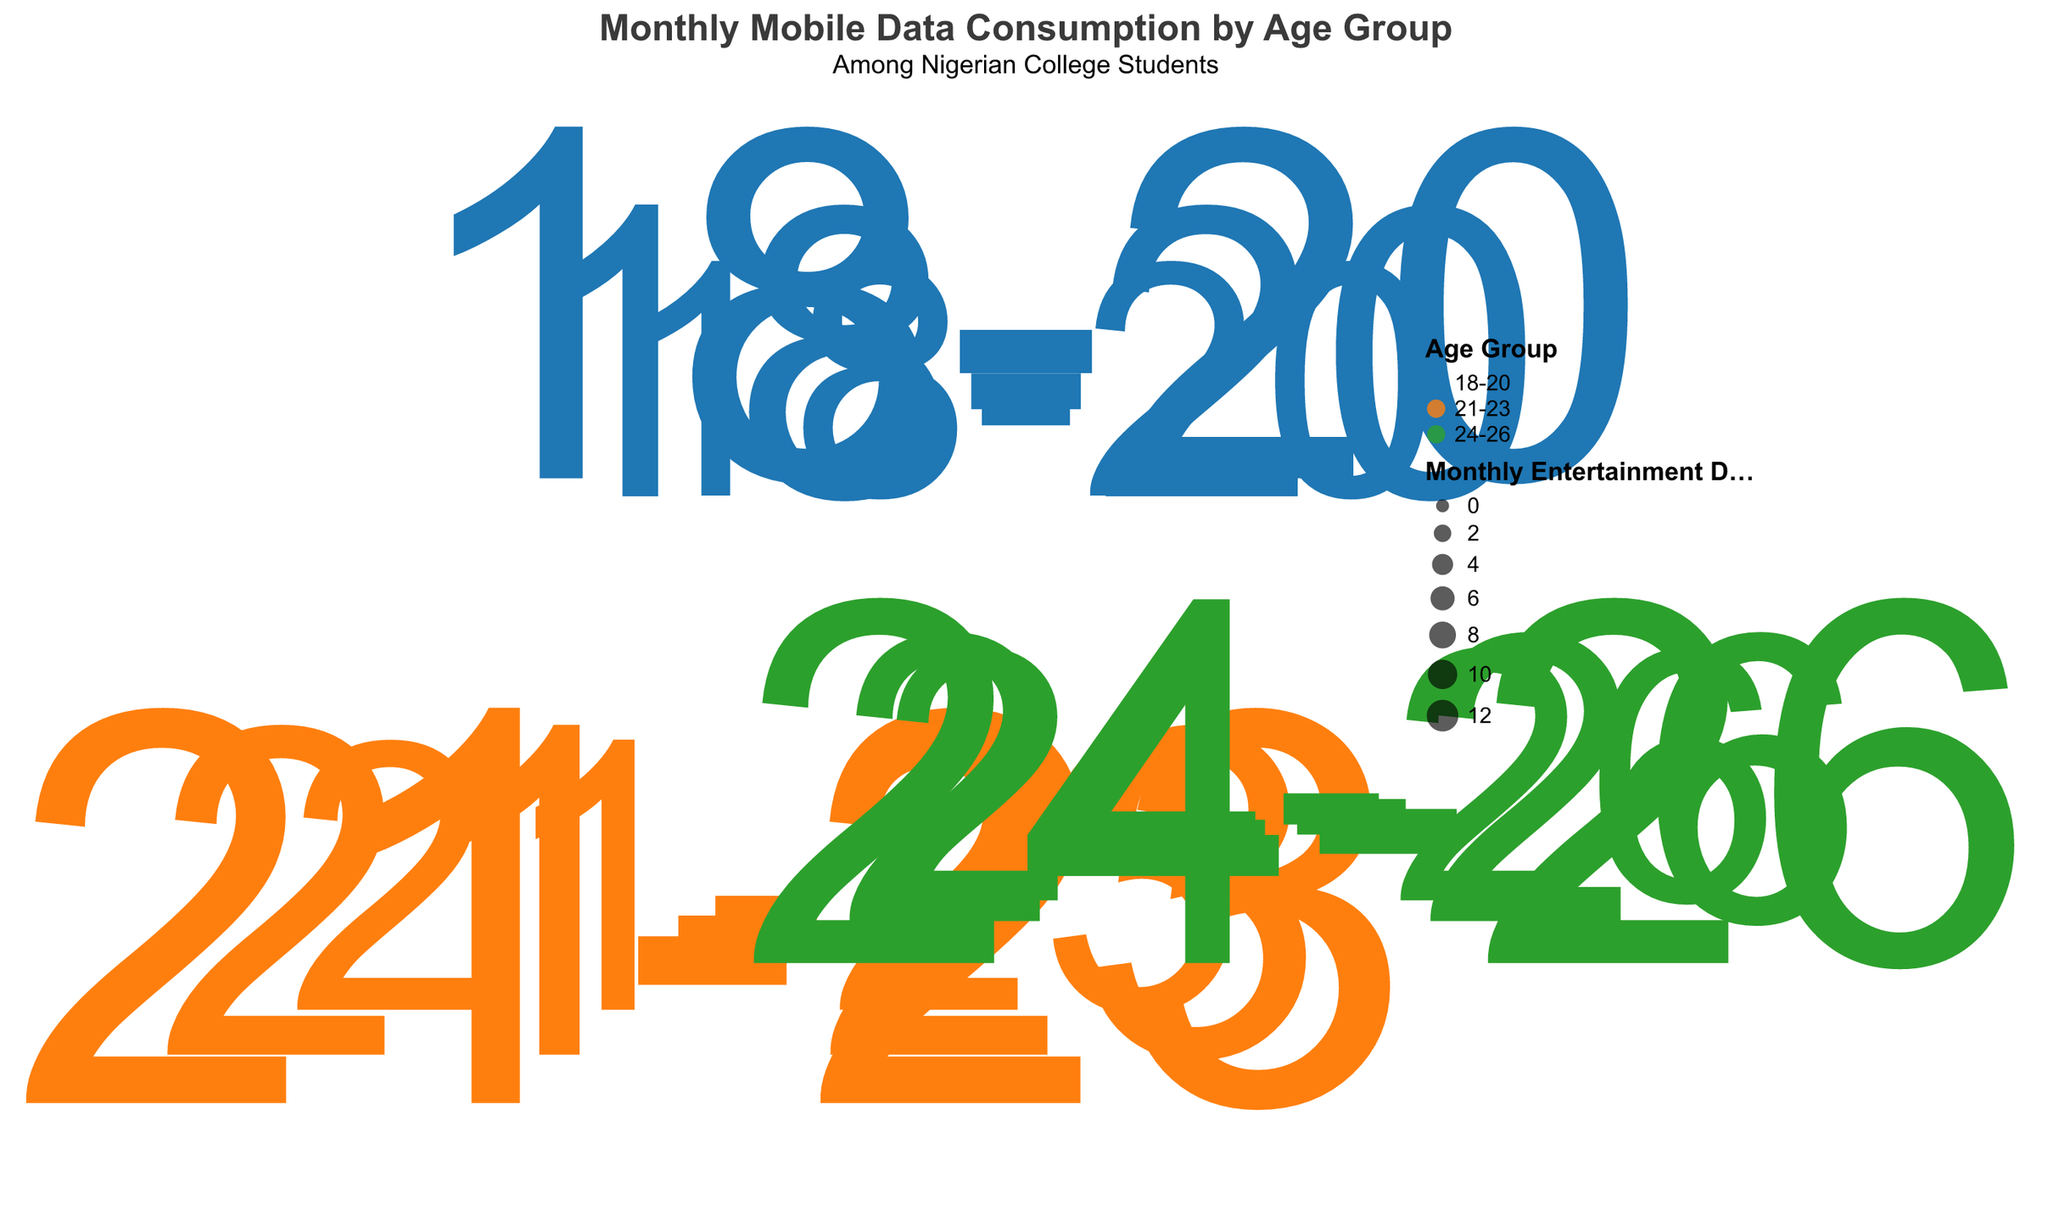What is the title of the chart? The chart title is usually placed at the top and is clearly visible. The chart's title gives an overview of what the chart is depicting.
Answer: Monthly Mobile Data Consumption by Age Group Which age group has the highest average monthly data consumption? By looking at the radial distance in the polar scatter chart, the longest radius from the center will indicate the highest average monthly data consumption.
Answer: 21-23 How many data points are there for the age group 24-26? Each point in the scatter plot represents a data point. By counting the points labeled "24-26", we can determine the number of data points.
Answer: 3 What is the size of the data point representing the highest monthly entertainment data for the age group 21-23? The size of points is proportional to the monthly entertainment data. Finding the largest point within the "21-23" age group will give us the answer.
Answer: 12.1 Compare the average monthly data consumption of the age groups 18-20 and 24-26. Which one is higher? Compare the radial distances from the center for the data points of both age groups. The larger distances will indicate higher average monthly data consumption.
Answer: 24-26 What is the average monthly educational data consumption for the age group 21-23 based on the given data points? Add the monthly educational data (5.5, 7.8, 4.0) for age group 21-23 and divide by the number of points (3). (5.5 + 7.8 + 4.0) / 3 = 5.7667
Answer: 5.8 Which age group generally uses more data for entertainment compared to educational purposes? Compare the sizes of the points (entertainment data) and match them with their corresponding age groups. Larger sized points will indicate higher entertainment data.
Answer: All age groups Within the age group 18-20, identify the data point with the smallest average monthly data consumption. Within the points labeled "18-20", find the point with the smallest radial distance from the chart center, indicating the smallest average monthly data consumption.
Answer: 12.9 How does the monthly entertainment data for the age group 24-26 compare with their monthly educational data? Look at the size of the points (entertainment data) and cross-reference with the tooltip showing educational data for the age group 24-26.
Answer: Entertainment data is higher Which fragment of the chart contains the most data points? The chart is divided into segments for each age group. Count the number of data points within each age group segment to determine the densest segment.
Answer: 18-20 What is the general trend in data consumption as age increases? Observing the position and distribution of points for each age group segment will show how average data consumption changes with age.
Answer: Increases 